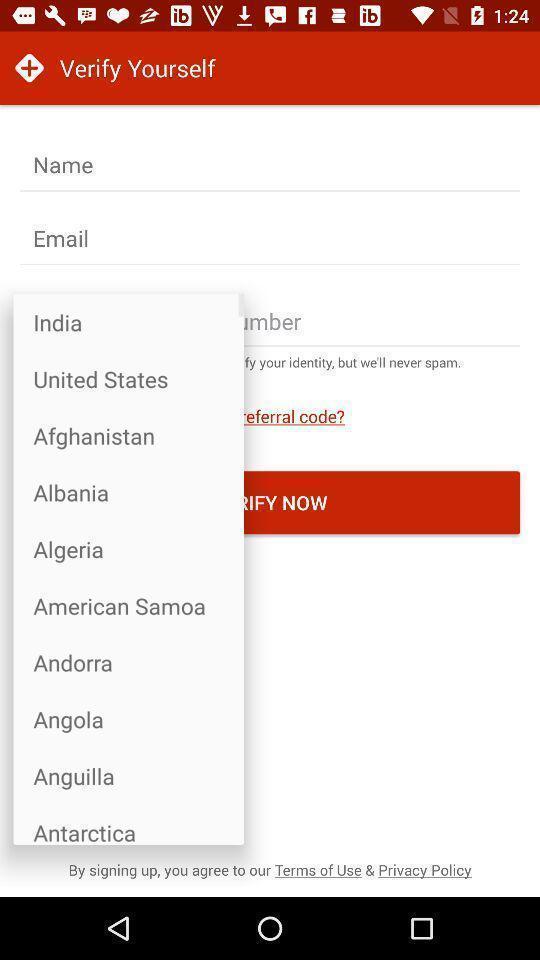Describe the visual elements of this screenshot. Popup to add in verification page of the doctor app. 